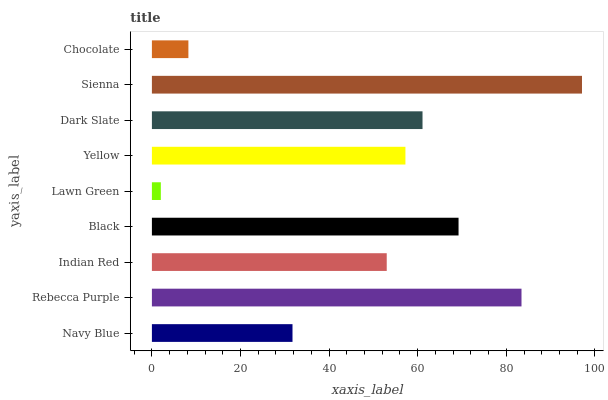Is Lawn Green the minimum?
Answer yes or no. Yes. Is Sienna the maximum?
Answer yes or no. Yes. Is Rebecca Purple the minimum?
Answer yes or no. No. Is Rebecca Purple the maximum?
Answer yes or no. No. Is Rebecca Purple greater than Navy Blue?
Answer yes or no. Yes. Is Navy Blue less than Rebecca Purple?
Answer yes or no. Yes. Is Navy Blue greater than Rebecca Purple?
Answer yes or no. No. Is Rebecca Purple less than Navy Blue?
Answer yes or no. No. Is Yellow the high median?
Answer yes or no. Yes. Is Yellow the low median?
Answer yes or no. Yes. Is Dark Slate the high median?
Answer yes or no. No. Is Black the low median?
Answer yes or no. No. 